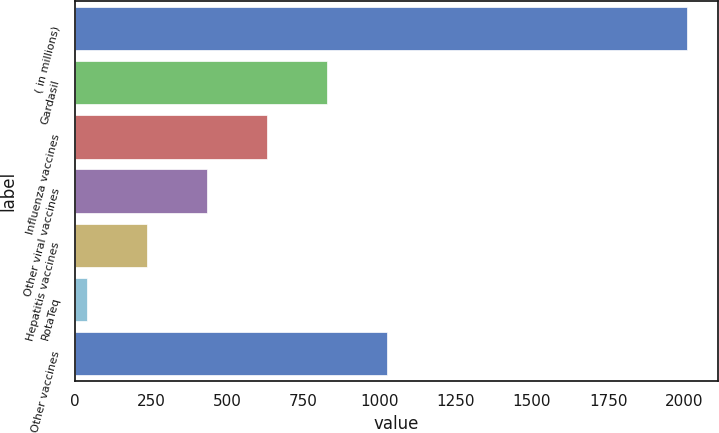<chart> <loc_0><loc_0><loc_500><loc_500><bar_chart><fcel>( in millions)<fcel>Gardasil<fcel>Influenza vaccines<fcel>Other viral vaccines<fcel>Hepatitis vaccines<fcel>RotaTeq<fcel>Other vaccines<nl><fcel>2009<fcel>828.92<fcel>632.24<fcel>435.56<fcel>238.88<fcel>42.2<fcel>1025.6<nl></chart> 